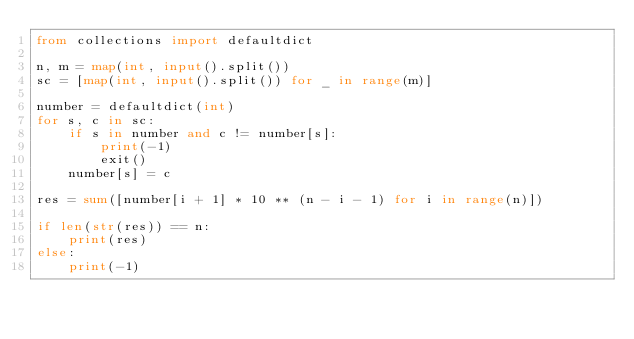Convert code to text. <code><loc_0><loc_0><loc_500><loc_500><_Python_>from collections import defaultdict

n, m = map(int, input().split())
sc = [map(int, input().split()) for _ in range(m)]

number = defaultdict(int)
for s, c in sc:
    if s in number and c != number[s]:
        print(-1)
        exit()
    number[s] = c

res = sum([number[i + 1] * 10 ** (n - i - 1) for i in range(n)])

if len(str(res)) == n:
    print(res)
else:
    print(-1)
</code> 